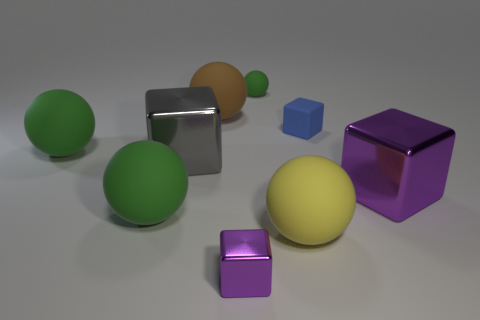Subtract all red blocks. How many green spheres are left? 3 Subtract all yellow rubber spheres. How many spheres are left? 4 Subtract all yellow spheres. How many spheres are left? 4 Subtract all red spheres. Subtract all red cylinders. How many spheres are left? 5 Add 1 large purple cubes. How many objects exist? 10 Subtract all cubes. How many objects are left? 5 Add 4 purple metal objects. How many purple metal objects exist? 6 Subtract 0 cyan blocks. How many objects are left? 9 Subtract all large gray metal things. Subtract all purple metallic spheres. How many objects are left? 8 Add 7 big brown spheres. How many big brown spheres are left? 8 